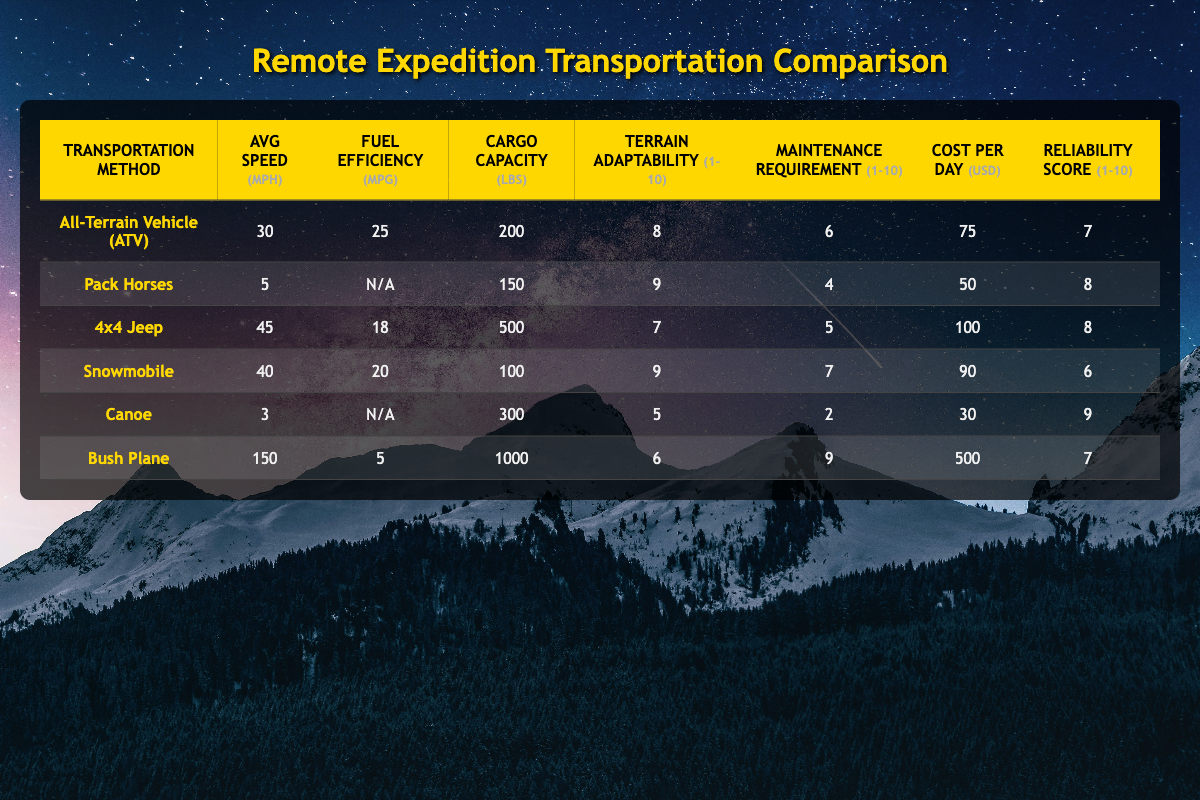what is the average speed of the 4x4 Jeep? The table shows that the 4x4 Jeep has an average speed of 45 mph.
Answer: 45 mph which transportation method has the highest cargo capacity? The cargo capacity of each method listed is compared: ATV (200 lbs), Pack Horses (150 lbs), 4x4 Jeep (500 lbs), Snowmobile (100 lbs), Canoe (300 lbs), and Bush Plane (1000 lbs). The Bush Plane has the highest cargo capacity at 1000 lbs.
Answer: Bush Plane is the fuel efficiency of Pack Horses available? The table states that the fuel efficiency of Pack Horses is listed as N/A (not applicable), meaning it is not available.
Answer: No which has a higher reliability score: All-Terrain Vehicle (ATV) or Snowmobile? The reliability scores are compared: ATV has a score of 7, while Snowmobile has a score of 6. Therefore, the ATV has a higher reliability score than the Snowmobile.
Answer: All-Terrain Vehicle (ATV) calculate the difference in cost per day between the most expensive and the least expensive transportation method. The cost per day for the methods are: ATV ($75), Pack Horses ($50), 4x4 Jeep ($100), Snowmobile ($90), Canoe ($30), and Bush Plane ($500). The most expensive is Bush Plane at $500 and the least expensive is Canoe at $30. The difference is 500 - 30 = $470.
Answer: $470 how many types of transportation have an avg speed greater than 30 mph? The methods with speeds greater than 30 mph are: 4x4 Jeep (45 mph), Snowmobile (40 mph), and Bush Plane (150 mph). There are 3 methods that fit this criterion.
Answer: 3 is the terrain adaptability of Canoe better than that of the 4x4 Jeep? Canoe has a terrain adaptability score of 5, while the 4x4 Jeep has a score of 7. A lower score indicates less adaptability, so Canoe is not better than the 4x4 Jeep.
Answer: No which method has the lowest maintenance requirement? The maintenance requirements are compared: ATV (6), Pack Horses (4), 4x4 Jeep (5), Snowmobile (7), Canoe (2), and Bush Plane (9). Canoe has the lowest maintenance requirement at 2.
Answer: Canoe 